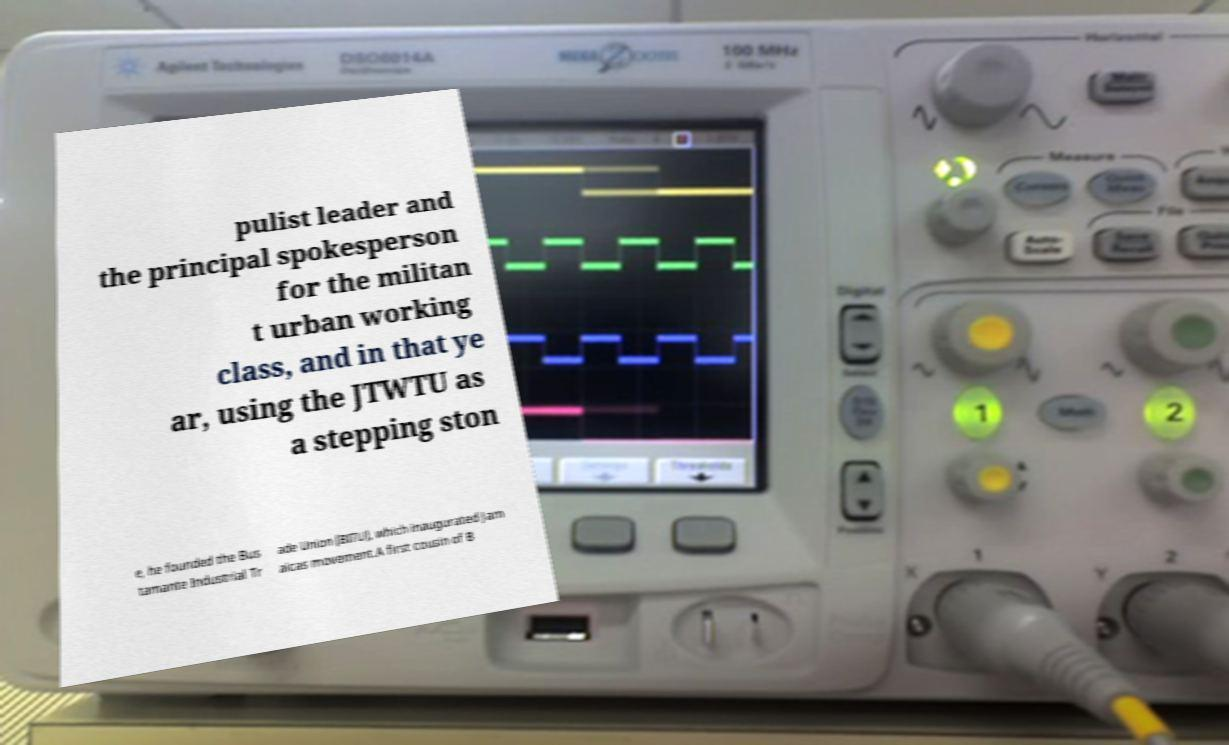Can you accurately transcribe the text from the provided image for me? pulist leader and the principal spokesperson for the militan t urban working class, and in that ye ar, using the JTWTU as a stepping ston e, he founded the Bus tamante Industrial Tr ade Union (BITU), which inaugurated Jam aicas movement.A first cousin of B 